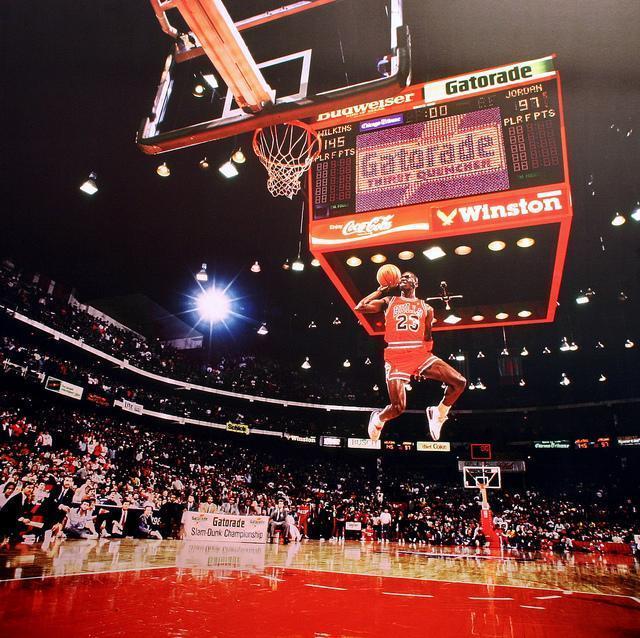How many people can you see?
Give a very brief answer. 2. 